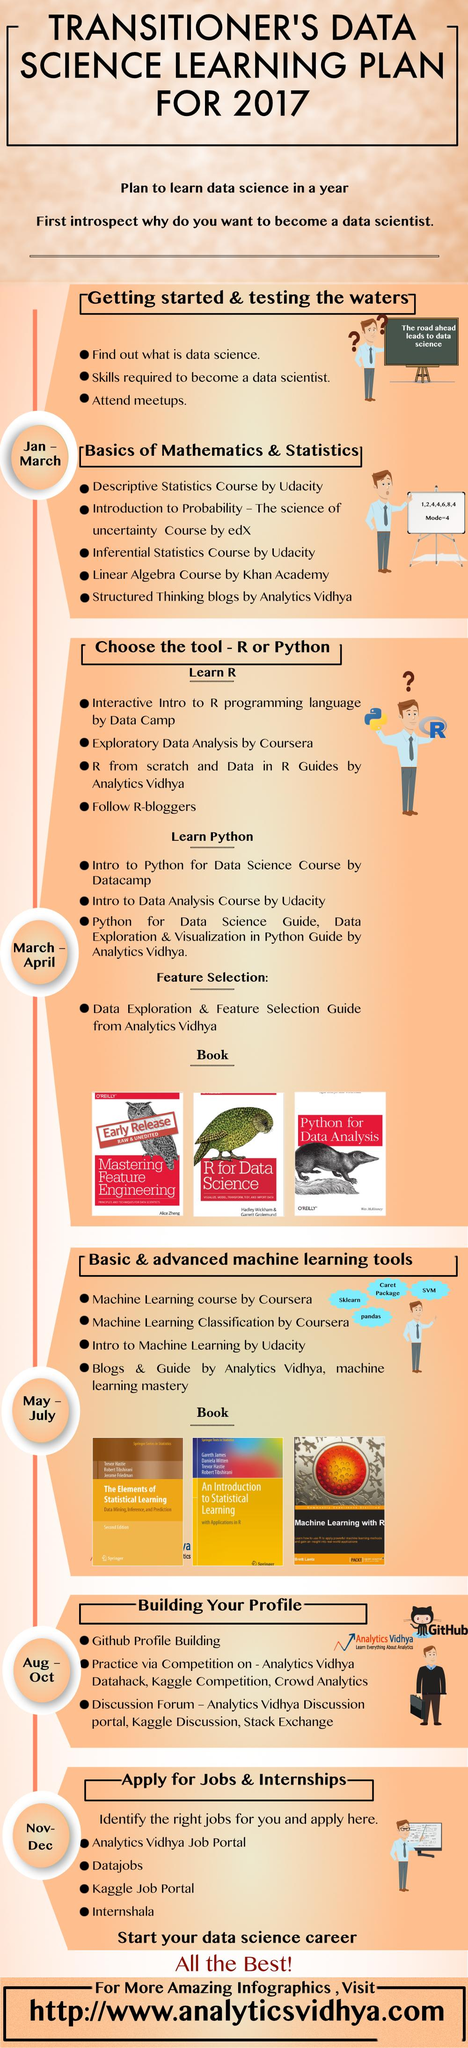Identify some key points in this picture. The infographic contains three advanced machine learning books. There are 3 books related to Python featured in this infographic. 